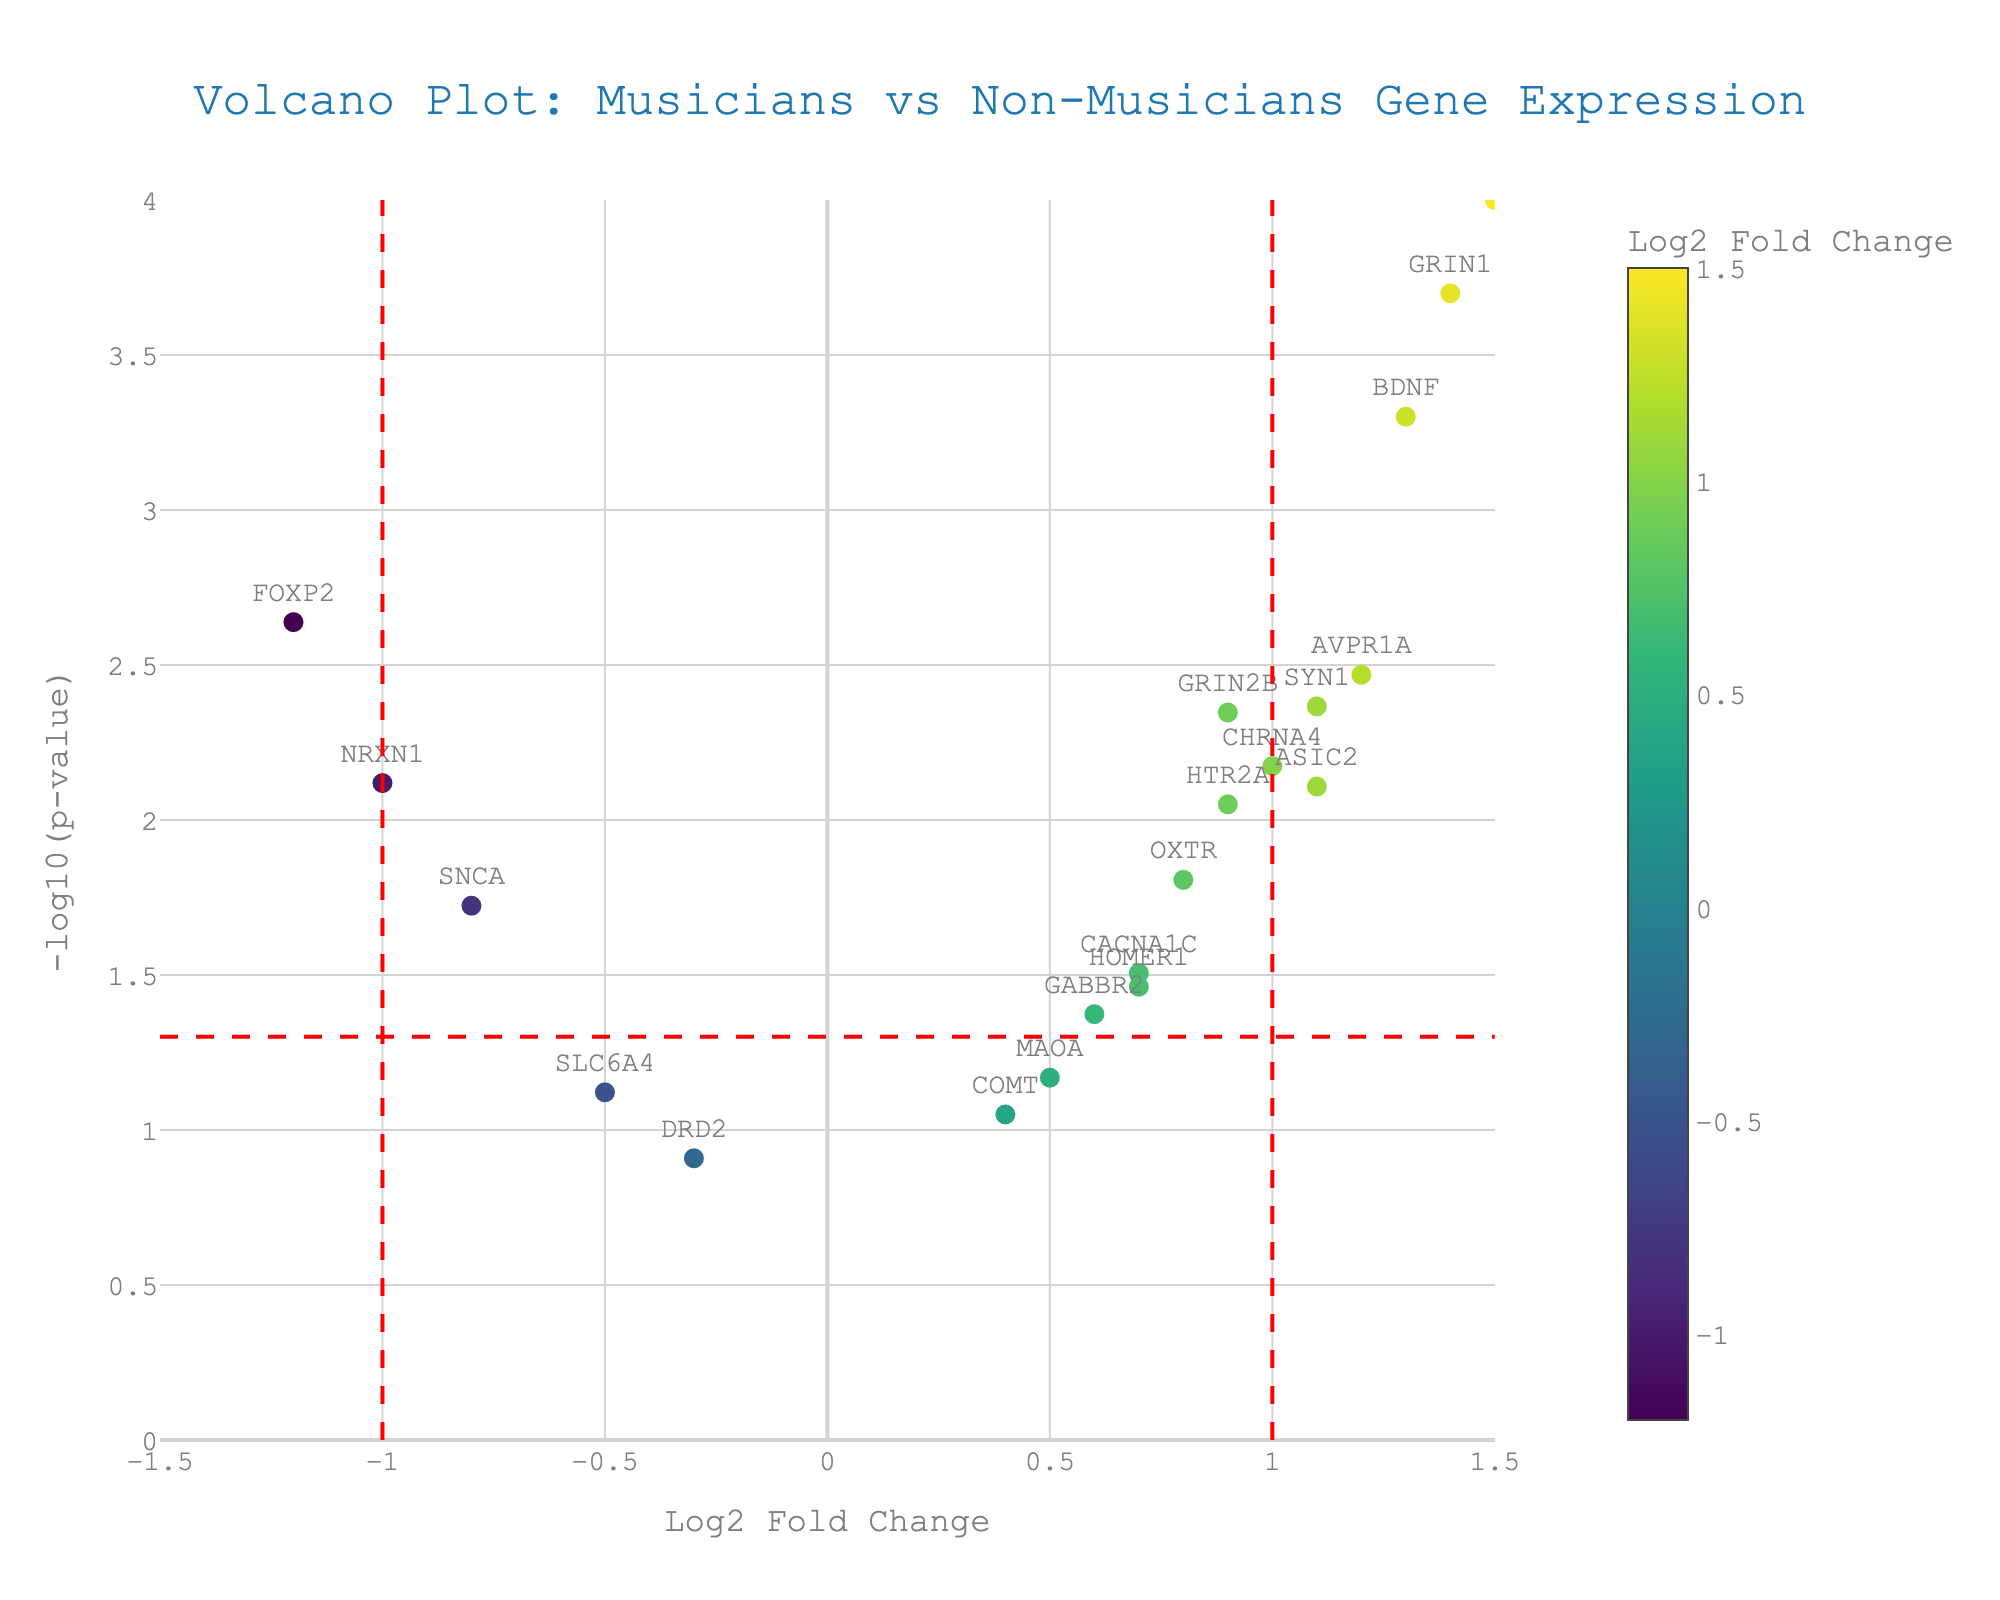What is the title of the figure? The title of the figure is located at the top and reads "Volcano Plot: Musicians vs Non-Musicians Gene Expression."
Answer: Volcano Plot: Musicians vs Non-Musicians Gene Expression Which gene has the highest -log10(p-value) and what is its value? To answer this, find the point on the y-axis with the greatest height. The gene closest to the top is CNTNAP2 with a corresponding -log10(p-value) value.
Answer: CNTNAP2, 4 How many genes have a Log2 Fold Change greater than 1? Look on the x-axis to the right of the line at Log2 Fold Change of 1 and count the points. There are 5 genes: CNTNAP2, BDNF, AVPR1A, GRIN1, SYN1.
Answer: 5 Identify a gene with a negative Log2 Fold Change and significant p-value (p < 0.05). A significant p-value corresponds to a -log10(p-value) above the red horizontal line (~1.3). Look for points on the left of the y-axis with these criteria. NRXN1 is one example.
Answer: NRXN1 What is the range of the -log10(p-value) in the plot? Identify the highest and lowest values on the y-axis from the data points. The range is between ~0.5 to ~4.
Answer: ~0.5 to ~4 Which gene has a Log2 Fold Change close to zero but is still statistically significant? Check points near the vertical line at Log2 Fold Change = 0 that lies above the horizontal line for significance. CHRNA4 falls close to these criteria.
Answer: CHRNA4 What threshold for significance is depicted by the red horizontal line? The red horizontal line indicates the significance threshold at -log10(p-value) corresponding to p-value = 0.05.
Answer: 1.3 Are any genes with nonsignificant p-values (p > 0.05) and a positive Log2 Fold Change? Look for points above the red horizontal line of 1.3 on the right of the y-axis. COMT and MAOA have nonsignificant p-values and positive fold changes.
Answer: COMT, MAOA Which gene has the lowest Log2 Fold Change, and what is its p-value? Identify the point furthest to the left on the x-axis and check its y-axis value. FOXP2 has the lowest Log2 Fold Change with a p-value of 0.0023.
Answer: FOXP2, 0.0023 What is the relationship between BDNF and SYN1 in terms of Log2 Fold Change and significance? Compare the x-axis positions for both genes (Log2 Fold Change) and whether they are above the significance threshold. BDNF (1.3) is slightly higher than SYN1 (1.1), and both are significant.
Answer: BDNF > SYN1 in Log2FC, both significant 